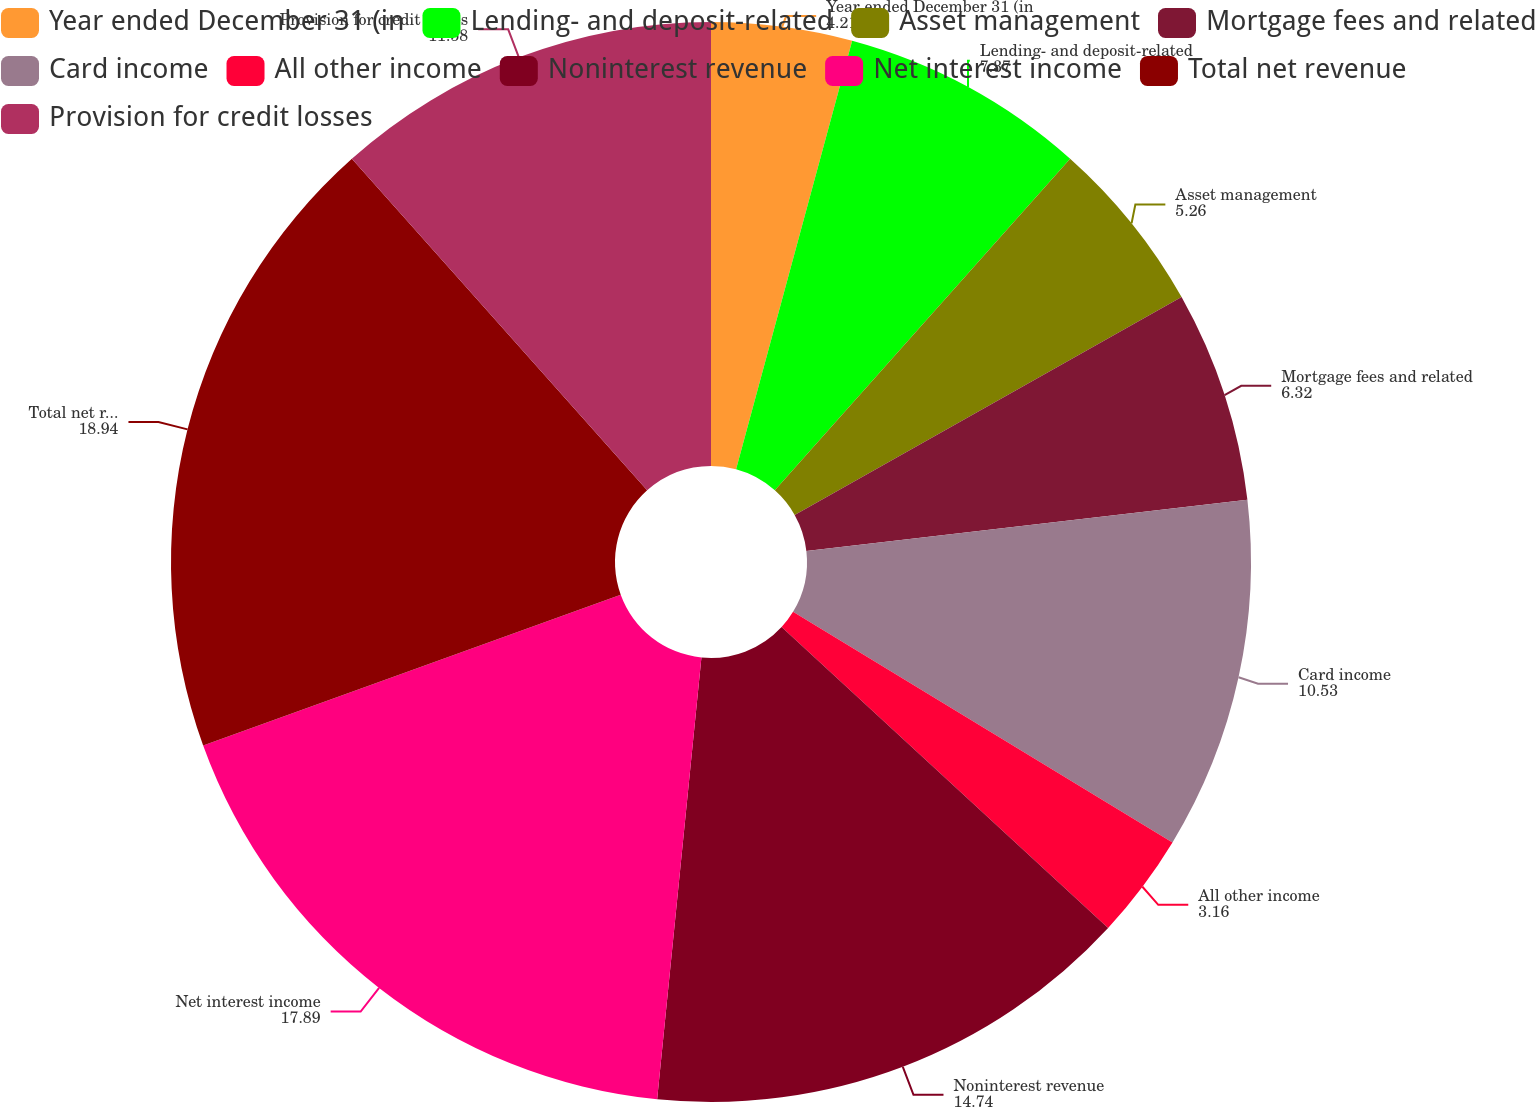Convert chart. <chart><loc_0><loc_0><loc_500><loc_500><pie_chart><fcel>Year ended December 31 (in<fcel>Lending- and deposit-related<fcel>Asset management<fcel>Mortgage fees and related<fcel>Card income<fcel>All other income<fcel>Noninterest revenue<fcel>Net interest income<fcel>Total net revenue<fcel>Provision for credit losses<nl><fcel>4.21%<fcel>7.37%<fcel>5.26%<fcel>6.32%<fcel>10.53%<fcel>3.16%<fcel>14.74%<fcel>17.89%<fcel>18.94%<fcel>11.58%<nl></chart> 